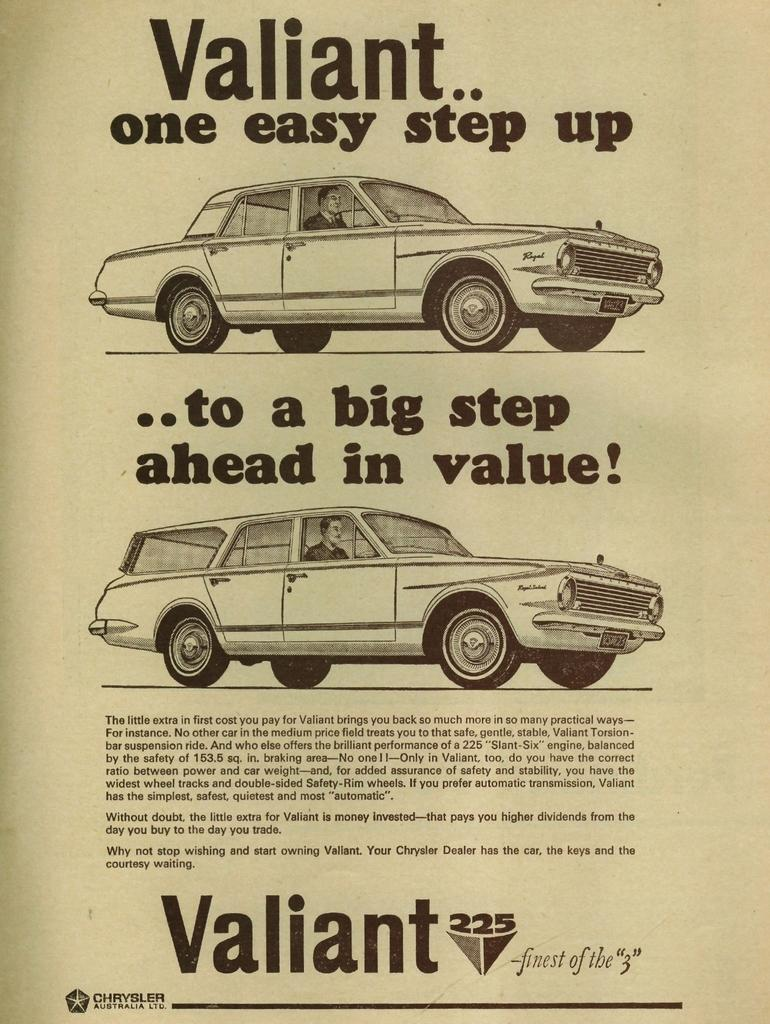What type of visual is the image? The image is a poster. What can be seen in the poster? There are cars in the image. Are there any words or letters in the image? Yes, there is text in the image. What is the rate of the wrench in the image? There is no wrench present in the image, so it is not possible to determine a rate for it. 